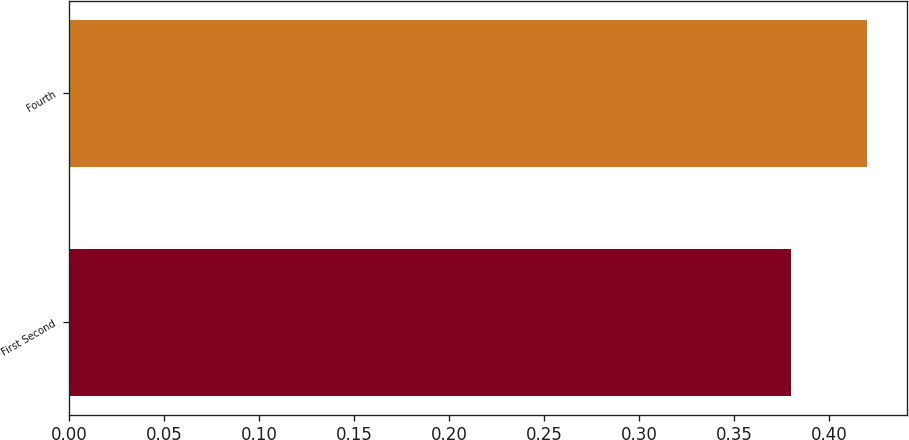<chart> <loc_0><loc_0><loc_500><loc_500><bar_chart><fcel>First Second<fcel>Fourth<nl><fcel>0.38<fcel>0.42<nl></chart> 